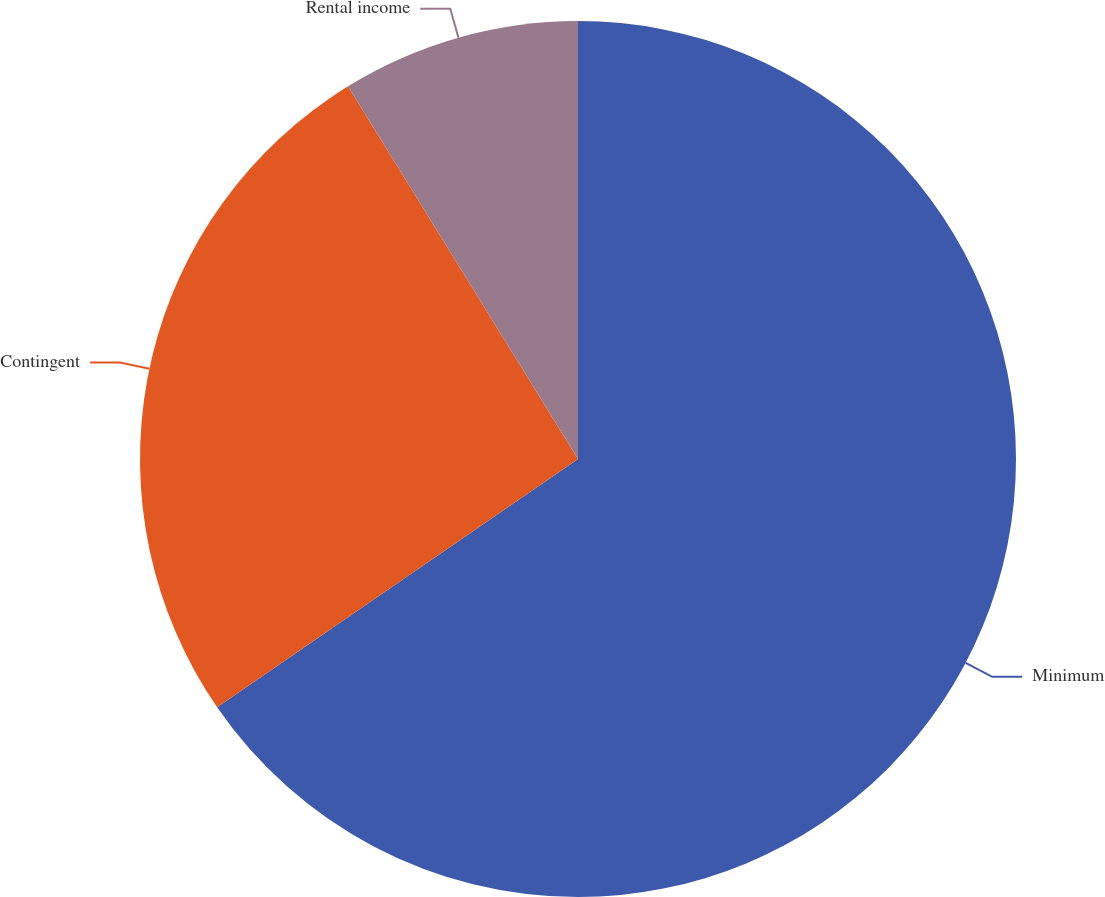<chart> <loc_0><loc_0><loc_500><loc_500><pie_chart><fcel>Minimum<fcel>Contingent<fcel>Rental income<nl><fcel>65.41%<fcel>25.79%<fcel>8.8%<nl></chart> 